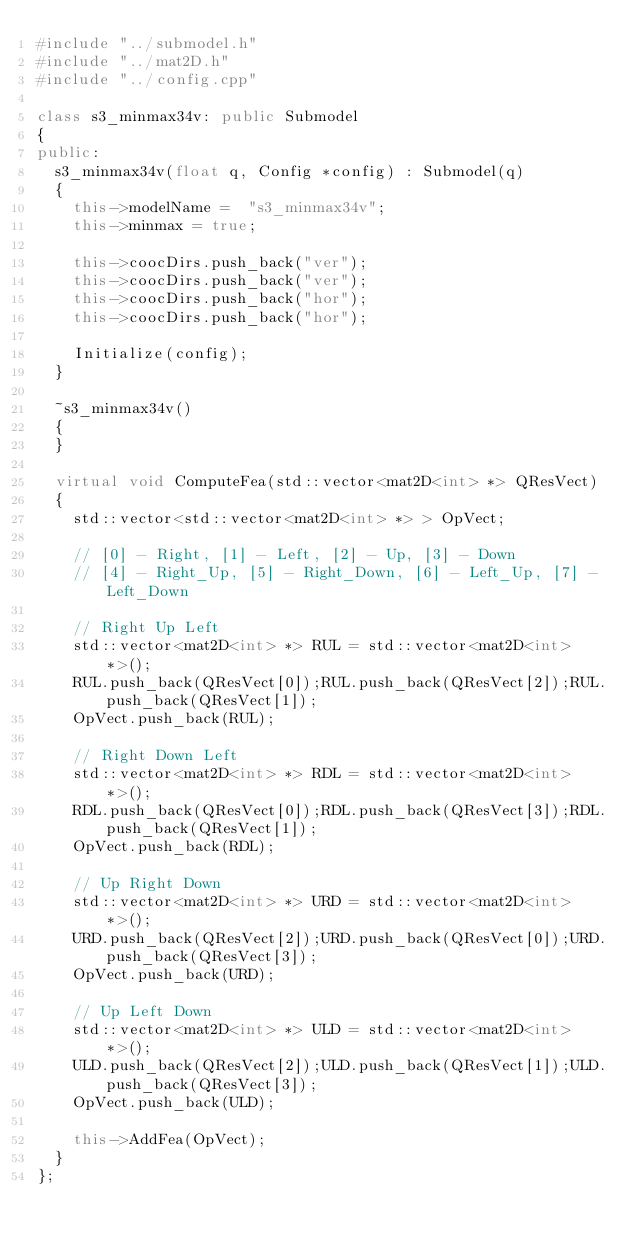<code> <loc_0><loc_0><loc_500><loc_500><_C++_>#include "../submodel.h"
#include "../mat2D.h"
#include "../config.cpp"

class s3_minmax34v: public Submodel
{
public:
	s3_minmax34v(float q, Config *config) : Submodel(q) 
	{
		this->modelName =  "s3_minmax34v";
		this->minmax = true;

		this->coocDirs.push_back("ver");
		this->coocDirs.push_back("ver");
		this->coocDirs.push_back("hor");
		this->coocDirs.push_back("hor");

		Initialize(config);
	}

	~s3_minmax34v()
	{
	}

	virtual void ComputeFea(std::vector<mat2D<int> *> QResVect)
	{
		std::vector<std::vector<mat2D<int> *> > OpVect;

		// [0] - Right, [1] - Left, [2] - Up, [3] - Down
		// [4] - Right_Up, [5] - Right_Down, [6] - Left_Up, [7] - Left_Down

		// Right Up Left
		std::vector<mat2D<int> *> RUL = std::vector<mat2D<int> *>();
		RUL.push_back(QResVect[0]);RUL.push_back(QResVect[2]);RUL.push_back(QResVect[1]);
		OpVect.push_back(RUL);

		// Right Down Left
		std::vector<mat2D<int> *> RDL = std::vector<mat2D<int> *>();
		RDL.push_back(QResVect[0]);RDL.push_back(QResVect[3]);RDL.push_back(QResVect[1]);
		OpVect.push_back(RDL);

		// Up Right Down
		std::vector<mat2D<int> *> URD = std::vector<mat2D<int> *>();
		URD.push_back(QResVect[2]);URD.push_back(QResVect[0]);URD.push_back(QResVect[3]);
		OpVect.push_back(URD);

		// Up Left Down
		std::vector<mat2D<int> *> ULD = std::vector<mat2D<int> *>();
		ULD.push_back(QResVect[2]);ULD.push_back(QResVect[1]);ULD.push_back(QResVect[3]);
		OpVect.push_back(ULD);

		this->AddFea(OpVect);
	}
};
</code> 